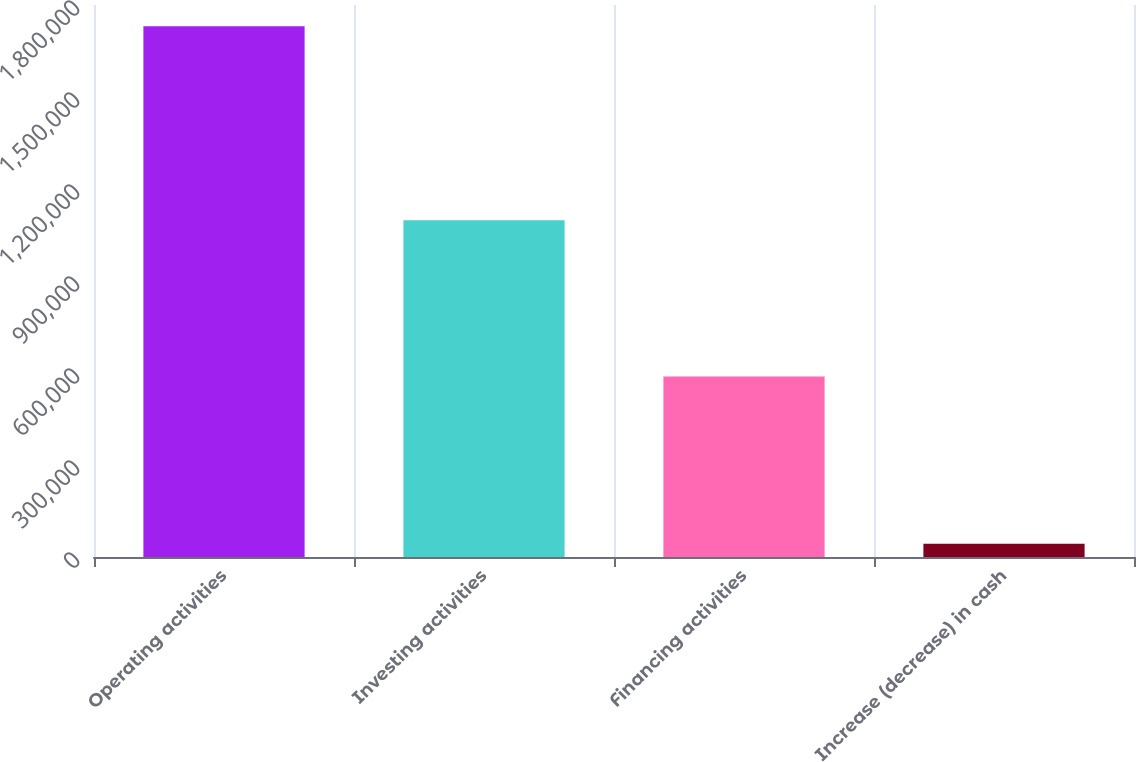Convert chart to OTSL. <chart><loc_0><loc_0><loc_500><loc_500><bar_chart><fcel>Operating activities<fcel>Investing activities<fcel>Financing activities<fcel>Increase (decrease) in cash<nl><fcel>1.73031e+06<fcel>1.09834e+06<fcel>588880<fcel>43087<nl></chart> 